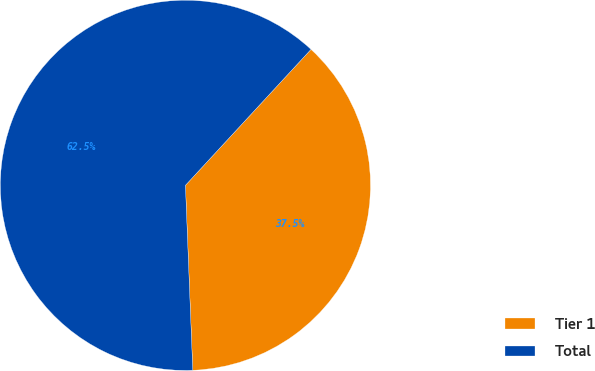Convert chart. <chart><loc_0><loc_0><loc_500><loc_500><pie_chart><fcel>Tier 1<fcel>Total<nl><fcel>37.5%<fcel>62.5%<nl></chart> 